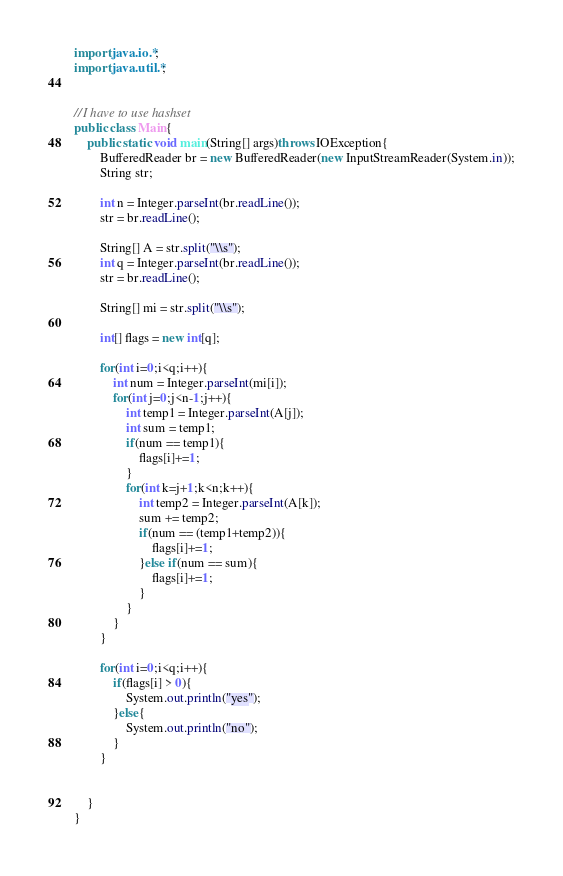<code> <loc_0><loc_0><loc_500><loc_500><_Java_>import java.io.*;
import java.util.*;


//I have to use hashset
public class Main{
    public static void main(String[] args)throws IOException{
        BufferedReader br = new BufferedReader(new InputStreamReader(System.in));
        String str;
        
        int n = Integer.parseInt(br.readLine());
        str = br.readLine();

        String[] A = str.split("\\s");
        int q = Integer.parseInt(br.readLine());
        str = br.readLine();

        String[] mi = str.split("\\s");

        int[] flags = new int[q];

        for(int i=0;i<q;i++){
            int num = Integer.parseInt(mi[i]);
            for(int j=0;j<n-1;j++){
                int temp1 = Integer.parseInt(A[j]);
                int sum = temp1;
                if(num == temp1){
                    flags[i]+=1;
                }
                for(int k=j+1;k<n;k++){
                    int temp2 = Integer.parseInt(A[k]);
                    sum += temp2;
                    if(num == (temp1+temp2)){
                        flags[i]+=1;
                    }else if(num == sum){
                        flags[i]+=1;
                    }
                }
            }
        }

        for(int i=0;i<q;i++){
            if(flags[i] > 0){
                System.out.println("yes");
            }else{
                System.out.println("no");
            }
        }
        

    }    
}

</code> 